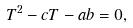Convert formula to latex. <formula><loc_0><loc_0><loc_500><loc_500>T ^ { 2 } - c T - a b = 0 ,</formula> 